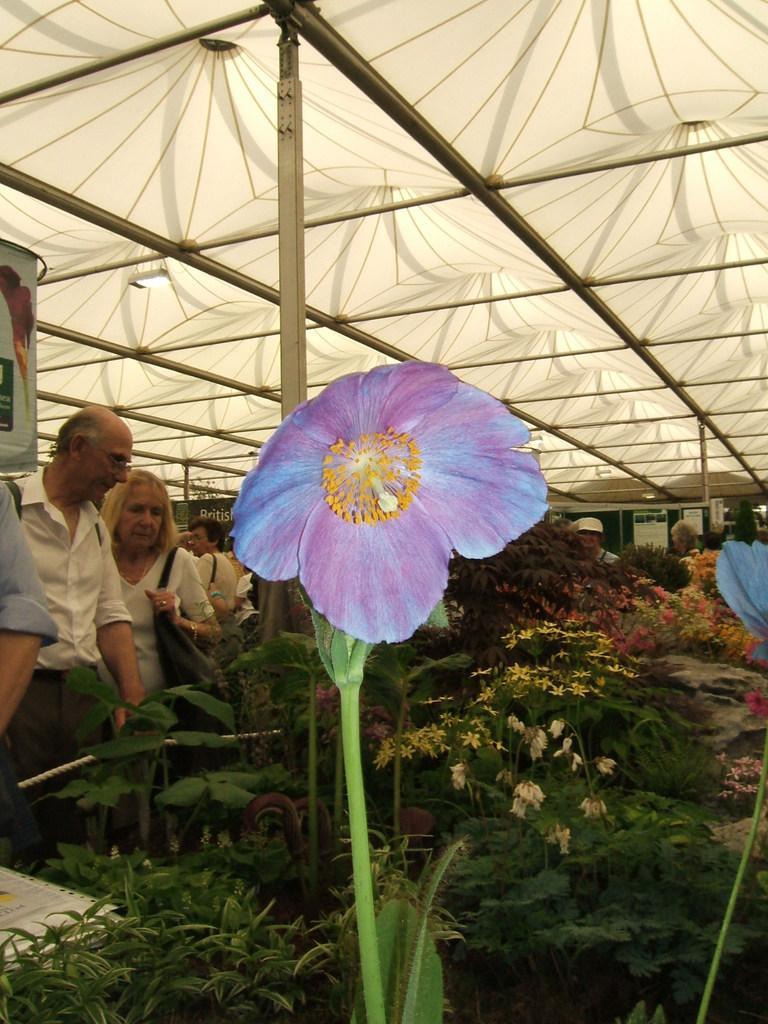Please provide a concise description of this image. In this image there is flower with stem. And there are many trees in the background. There are people. There is white color roof. 